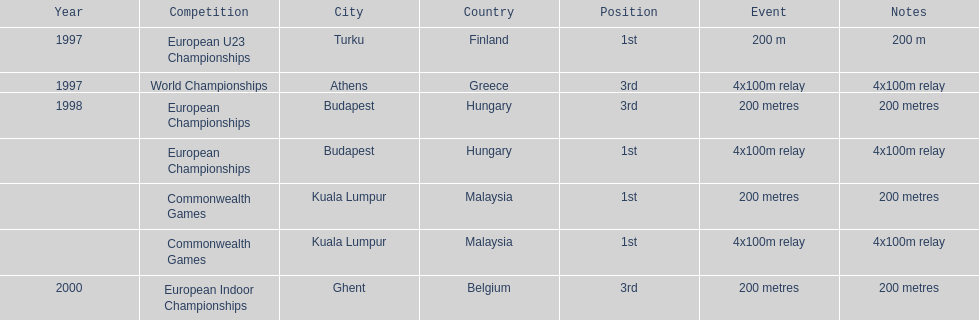How long was the sprint from the european indoor championships competition in 2000? 200 metres. 